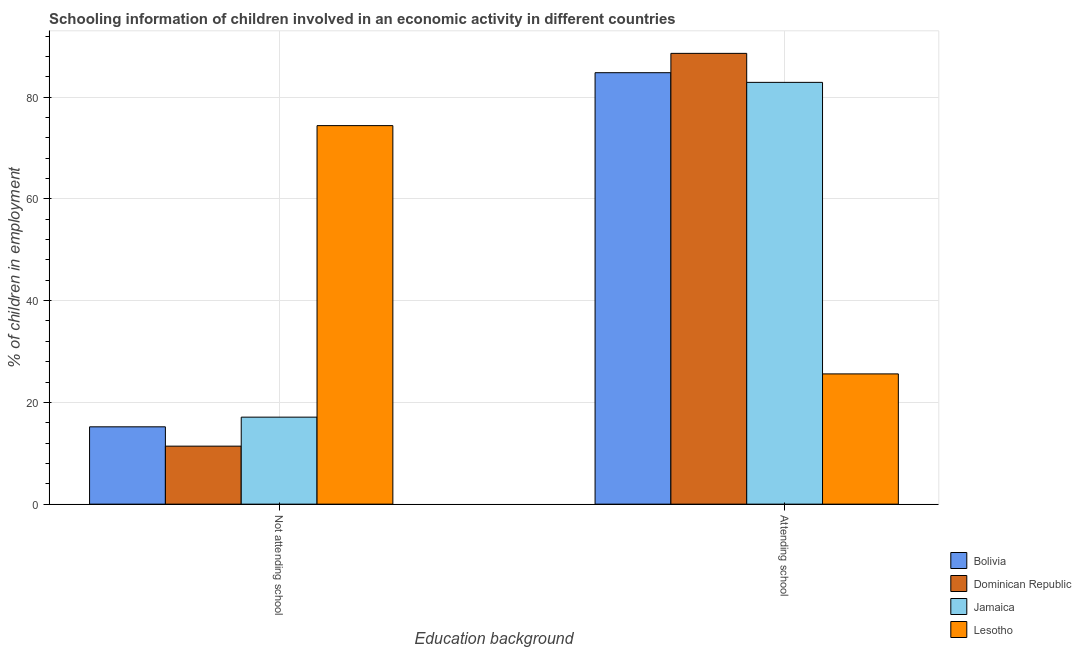Are the number of bars per tick equal to the number of legend labels?
Provide a succinct answer. Yes. Are the number of bars on each tick of the X-axis equal?
Your answer should be compact. Yes. How many bars are there on the 2nd tick from the right?
Make the answer very short. 4. What is the label of the 1st group of bars from the left?
Provide a succinct answer. Not attending school. What is the percentage of employed children who are not attending school in Lesotho?
Your answer should be compact. 74.4. Across all countries, what is the maximum percentage of employed children who are not attending school?
Provide a short and direct response. 74.4. In which country was the percentage of employed children who are attending school maximum?
Keep it short and to the point. Dominican Republic. In which country was the percentage of employed children who are attending school minimum?
Your answer should be compact. Lesotho. What is the total percentage of employed children who are attending school in the graph?
Provide a short and direct response. 281.9. What is the difference between the percentage of employed children who are attending school in Bolivia and that in Lesotho?
Keep it short and to the point. 59.2. What is the difference between the percentage of employed children who are not attending school in Dominican Republic and the percentage of employed children who are attending school in Bolivia?
Your answer should be compact. -73.4. What is the average percentage of employed children who are not attending school per country?
Your answer should be very brief. 29.53. What is the difference between the percentage of employed children who are not attending school and percentage of employed children who are attending school in Jamaica?
Your answer should be very brief. -65.8. What is the ratio of the percentage of employed children who are not attending school in Lesotho to that in Bolivia?
Give a very brief answer. 4.89. Is the percentage of employed children who are not attending school in Jamaica less than that in Bolivia?
Your answer should be very brief. No. What does the 2nd bar from the left in Attending school represents?
Your response must be concise. Dominican Republic. What does the 2nd bar from the right in Attending school represents?
Keep it short and to the point. Jamaica. How many bars are there?
Your answer should be very brief. 8. Are all the bars in the graph horizontal?
Ensure brevity in your answer.  No. How many countries are there in the graph?
Keep it short and to the point. 4. What is the difference between two consecutive major ticks on the Y-axis?
Your response must be concise. 20. Does the graph contain grids?
Keep it short and to the point. Yes. What is the title of the graph?
Offer a terse response. Schooling information of children involved in an economic activity in different countries. Does "Korea (Republic)" appear as one of the legend labels in the graph?
Ensure brevity in your answer.  No. What is the label or title of the X-axis?
Provide a short and direct response. Education background. What is the label or title of the Y-axis?
Offer a terse response. % of children in employment. What is the % of children in employment in Bolivia in Not attending school?
Your answer should be very brief. 15.2. What is the % of children in employment of Jamaica in Not attending school?
Your answer should be very brief. 17.1. What is the % of children in employment in Lesotho in Not attending school?
Offer a terse response. 74.4. What is the % of children in employment in Bolivia in Attending school?
Make the answer very short. 84.8. What is the % of children in employment of Dominican Republic in Attending school?
Provide a succinct answer. 88.6. What is the % of children in employment in Jamaica in Attending school?
Provide a succinct answer. 82.9. What is the % of children in employment of Lesotho in Attending school?
Your response must be concise. 25.6. Across all Education background, what is the maximum % of children in employment in Bolivia?
Your answer should be very brief. 84.8. Across all Education background, what is the maximum % of children in employment in Dominican Republic?
Your answer should be compact. 88.6. Across all Education background, what is the maximum % of children in employment of Jamaica?
Give a very brief answer. 82.9. Across all Education background, what is the maximum % of children in employment in Lesotho?
Give a very brief answer. 74.4. Across all Education background, what is the minimum % of children in employment of Bolivia?
Your answer should be compact. 15.2. Across all Education background, what is the minimum % of children in employment in Dominican Republic?
Offer a very short reply. 11.4. Across all Education background, what is the minimum % of children in employment in Lesotho?
Provide a succinct answer. 25.6. What is the total % of children in employment of Jamaica in the graph?
Ensure brevity in your answer.  100. What is the difference between the % of children in employment in Bolivia in Not attending school and that in Attending school?
Offer a terse response. -69.6. What is the difference between the % of children in employment in Dominican Republic in Not attending school and that in Attending school?
Keep it short and to the point. -77.2. What is the difference between the % of children in employment in Jamaica in Not attending school and that in Attending school?
Your answer should be very brief. -65.8. What is the difference between the % of children in employment in Lesotho in Not attending school and that in Attending school?
Offer a terse response. 48.8. What is the difference between the % of children in employment of Bolivia in Not attending school and the % of children in employment of Dominican Republic in Attending school?
Keep it short and to the point. -73.4. What is the difference between the % of children in employment of Bolivia in Not attending school and the % of children in employment of Jamaica in Attending school?
Your answer should be very brief. -67.7. What is the difference between the % of children in employment of Dominican Republic in Not attending school and the % of children in employment of Jamaica in Attending school?
Ensure brevity in your answer.  -71.5. What is the average % of children in employment of Bolivia per Education background?
Give a very brief answer. 50. What is the difference between the % of children in employment in Bolivia and % of children in employment in Jamaica in Not attending school?
Give a very brief answer. -1.9. What is the difference between the % of children in employment in Bolivia and % of children in employment in Lesotho in Not attending school?
Your answer should be very brief. -59.2. What is the difference between the % of children in employment of Dominican Republic and % of children in employment of Jamaica in Not attending school?
Your answer should be very brief. -5.7. What is the difference between the % of children in employment of Dominican Republic and % of children in employment of Lesotho in Not attending school?
Give a very brief answer. -63. What is the difference between the % of children in employment in Jamaica and % of children in employment in Lesotho in Not attending school?
Make the answer very short. -57.3. What is the difference between the % of children in employment in Bolivia and % of children in employment in Lesotho in Attending school?
Make the answer very short. 59.2. What is the difference between the % of children in employment of Dominican Republic and % of children in employment of Jamaica in Attending school?
Offer a very short reply. 5.7. What is the difference between the % of children in employment in Dominican Republic and % of children in employment in Lesotho in Attending school?
Keep it short and to the point. 63. What is the difference between the % of children in employment of Jamaica and % of children in employment of Lesotho in Attending school?
Provide a succinct answer. 57.3. What is the ratio of the % of children in employment of Bolivia in Not attending school to that in Attending school?
Your answer should be compact. 0.18. What is the ratio of the % of children in employment of Dominican Republic in Not attending school to that in Attending school?
Provide a succinct answer. 0.13. What is the ratio of the % of children in employment in Jamaica in Not attending school to that in Attending school?
Make the answer very short. 0.21. What is the ratio of the % of children in employment in Lesotho in Not attending school to that in Attending school?
Give a very brief answer. 2.91. What is the difference between the highest and the second highest % of children in employment in Bolivia?
Offer a very short reply. 69.6. What is the difference between the highest and the second highest % of children in employment of Dominican Republic?
Offer a terse response. 77.2. What is the difference between the highest and the second highest % of children in employment of Jamaica?
Keep it short and to the point. 65.8. What is the difference between the highest and the second highest % of children in employment of Lesotho?
Ensure brevity in your answer.  48.8. What is the difference between the highest and the lowest % of children in employment of Bolivia?
Make the answer very short. 69.6. What is the difference between the highest and the lowest % of children in employment of Dominican Republic?
Provide a succinct answer. 77.2. What is the difference between the highest and the lowest % of children in employment of Jamaica?
Offer a very short reply. 65.8. What is the difference between the highest and the lowest % of children in employment of Lesotho?
Offer a very short reply. 48.8. 